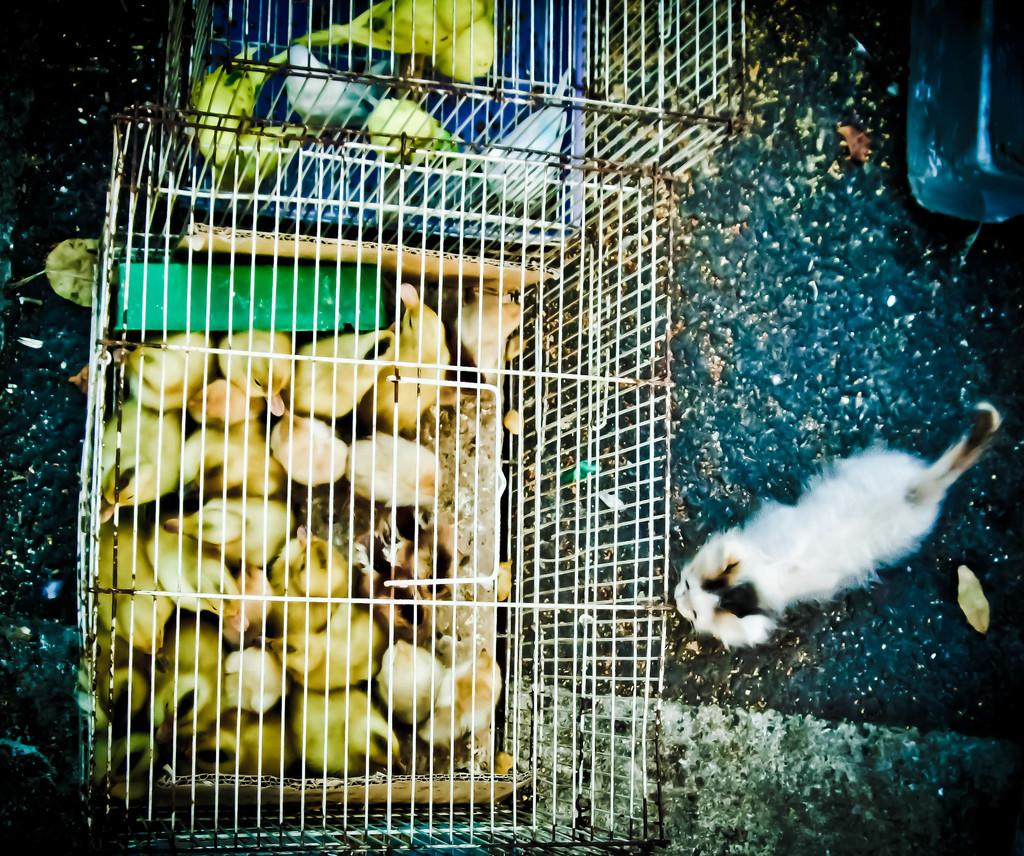What type of animals are in the image? There is a group of chicks in the image. Where are the chicks located? The chicks are in cages. What other animal can be seen in the image? There is a cat in the image. What type of vegetation is present in the image? Dried leaves are present in the image. What object is on the ground in the image? There is an object on the ground in the image. Where is the goose in the image? There is no goose present in the image. What type of faucet can be seen in the image? There is no faucet present in the image. 